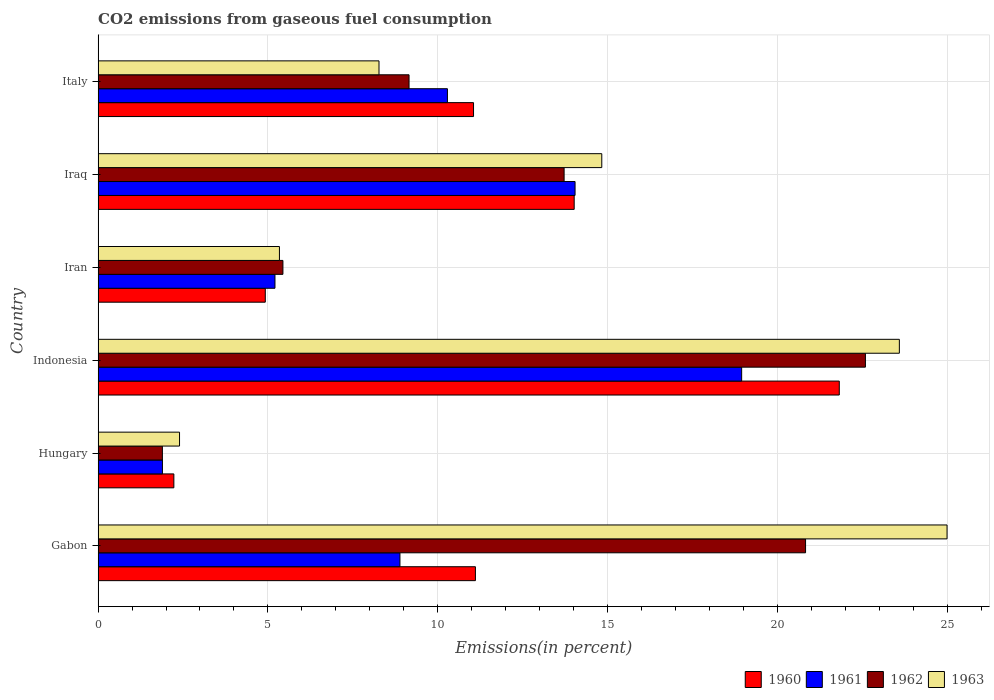How many different coloured bars are there?
Your answer should be very brief. 4. What is the label of the 6th group of bars from the top?
Make the answer very short. Gabon. What is the total CO2 emitted in 1960 in Iran?
Provide a succinct answer. 4.92. Across all countries, what is the maximum total CO2 emitted in 1961?
Ensure brevity in your answer.  18.95. Across all countries, what is the minimum total CO2 emitted in 1962?
Your answer should be compact. 1.89. In which country was the total CO2 emitted in 1963 maximum?
Keep it short and to the point. Gabon. In which country was the total CO2 emitted in 1960 minimum?
Your answer should be very brief. Hungary. What is the total total CO2 emitted in 1962 in the graph?
Offer a very short reply. 73.64. What is the difference between the total CO2 emitted in 1963 in Gabon and that in Italy?
Your answer should be very brief. 16.73. What is the difference between the total CO2 emitted in 1962 in Gabon and the total CO2 emitted in 1960 in Indonesia?
Offer a terse response. -0.99. What is the average total CO2 emitted in 1960 per country?
Offer a terse response. 10.86. What is the difference between the total CO2 emitted in 1961 and total CO2 emitted in 1960 in Indonesia?
Your answer should be compact. -2.87. In how many countries, is the total CO2 emitted in 1962 greater than 14 %?
Provide a short and direct response. 2. What is the ratio of the total CO2 emitted in 1963 in Indonesia to that in Iran?
Your response must be concise. 4.42. What is the difference between the highest and the second highest total CO2 emitted in 1962?
Give a very brief answer. 1.76. What is the difference between the highest and the lowest total CO2 emitted in 1961?
Offer a very short reply. 17.06. In how many countries, is the total CO2 emitted in 1962 greater than the average total CO2 emitted in 1962 taken over all countries?
Offer a terse response. 3. Is the sum of the total CO2 emitted in 1962 in Gabon and Iran greater than the maximum total CO2 emitted in 1960 across all countries?
Provide a short and direct response. Yes. Is it the case that in every country, the sum of the total CO2 emitted in 1963 and total CO2 emitted in 1960 is greater than the sum of total CO2 emitted in 1961 and total CO2 emitted in 1962?
Your response must be concise. No. What does the 4th bar from the top in Iraq represents?
Your answer should be compact. 1960. What does the 4th bar from the bottom in Gabon represents?
Make the answer very short. 1963. Is it the case that in every country, the sum of the total CO2 emitted in 1960 and total CO2 emitted in 1963 is greater than the total CO2 emitted in 1961?
Provide a short and direct response. Yes. How many bars are there?
Make the answer very short. 24. How many countries are there in the graph?
Provide a succinct answer. 6. How are the legend labels stacked?
Your response must be concise. Horizontal. What is the title of the graph?
Your answer should be compact. CO2 emissions from gaseous fuel consumption. What is the label or title of the X-axis?
Offer a very short reply. Emissions(in percent). What is the label or title of the Y-axis?
Your answer should be compact. Country. What is the Emissions(in percent) in 1960 in Gabon?
Your answer should be very brief. 11.11. What is the Emissions(in percent) of 1961 in Gabon?
Ensure brevity in your answer.  8.89. What is the Emissions(in percent) of 1962 in Gabon?
Offer a terse response. 20.83. What is the Emissions(in percent) in 1963 in Gabon?
Provide a short and direct response. 25. What is the Emissions(in percent) of 1960 in Hungary?
Your answer should be very brief. 2.23. What is the Emissions(in percent) in 1961 in Hungary?
Ensure brevity in your answer.  1.89. What is the Emissions(in percent) in 1962 in Hungary?
Provide a short and direct response. 1.89. What is the Emissions(in percent) in 1963 in Hungary?
Your answer should be very brief. 2.4. What is the Emissions(in percent) of 1960 in Indonesia?
Your answer should be compact. 21.83. What is the Emissions(in percent) of 1961 in Indonesia?
Provide a short and direct response. 18.95. What is the Emissions(in percent) in 1962 in Indonesia?
Offer a very short reply. 22.6. What is the Emissions(in percent) of 1963 in Indonesia?
Provide a succinct answer. 23.6. What is the Emissions(in percent) of 1960 in Iran?
Offer a terse response. 4.92. What is the Emissions(in percent) in 1961 in Iran?
Your answer should be compact. 5.21. What is the Emissions(in percent) of 1962 in Iran?
Ensure brevity in your answer.  5.44. What is the Emissions(in percent) in 1963 in Iran?
Keep it short and to the point. 5.34. What is the Emissions(in percent) of 1960 in Iraq?
Your response must be concise. 14.02. What is the Emissions(in percent) of 1961 in Iraq?
Your answer should be very brief. 14.05. What is the Emissions(in percent) in 1962 in Iraq?
Your response must be concise. 13.72. What is the Emissions(in percent) of 1963 in Iraq?
Make the answer very short. 14.83. What is the Emissions(in percent) of 1960 in Italy?
Your response must be concise. 11.06. What is the Emissions(in percent) of 1961 in Italy?
Offer a terse response. 10.29. What is the Emissions(in percent) in 1962 in Italy?
Provide a short and direct response. 9.16. What is the Emissions(in percent) in 1963 in Italy?
Your answer should be very brief. 8.27. Across all countries, what is the maximum Emissions(in percent) of 1960?
Provide a succinct answer. 21.83. Across all countries, what is the maximum Emissions(in percent) of 1961?
Give a very brief answer. 18.95. Across all countries, what is the maximum Emissions(in percent) in 1962?
Your response must be concise. 22.6. Across all countries, what is the maximum Emissions(in percent) of 1963?
Ensure brevity in your answer.  25. Across all countries, what is the minimum Emissions(in percent) of 1960?
Offer a very short reply. 2.23. Across all countries, what is the minimum Emissions(in percent) in 1961?
Offer a terse response. 1.89. Across all countries, what is the minimum Emissions(in percent) in 1962?
Provide a succinct answer. 1.89. Across all countries, what is the minimum Emissions(in percent) of 1963?
Your answer should be very brief. 2.4. What is the total Emissions(in percent) of 1960 in the graph?
Your answer should be very brief. 65.17. What is the total Emissions(in percent) in 1961 in the graph?
Keep it short and to the point. 59.28. What is the total Emissions(in percent) in 1962 in the graph?
Your response must be concise. 73.64. What is the total Emissions(in percent) in 1963 in the graph?
Provide a succinct answer. 79.44. What is the difference between the Emissions(in percent) in 1960 in Gabon and that in Hungary?
Provide a short and direct response. 8.88. What is the difference between the Emissions(in percent) in 1961 in Gabon and that in Hungary?
Ensure brevity in your answer.  6.99. What is the difference between the Emissions(in percent) of 1962 in Gabon and that in Hungary?
Provide a succinct answer. 18.94. What is the difference between the Emissions(in percent) of 1963 in Gabon and that in Hungary?
Your answer should be compact. 22.6. What is the difference between the Emissions(in percent) in 1960 in Gabon and that in Indonesia?
Give a very brief answer. -10.72. What is the difference between the Emissions(in percent) of 1961 in Gabon and that in Indonesia?
Your answer should be compact. -10.06. What is the difference between the Emissions(in percent) in 1962 in Gabon and that in Indonesia?
Keep it short and to the point. -1.76. What is the difference between the Emissions(in percent) of 1963 in Gabon and that in Indonesia?
Make the answer very short. 1.4. What is the difference between the Emissions(in percent) of 1960 in Gabon and that in Iran?
Your answer should be very brief. 6.19. What is the difference between the Emissions(in percent) of 1961 in Gabon and that in Iran?
Your response must be concise. 3.68. What is the difference between the Emissions(in percent) in 1962 in Gabon and that in Iran?
Your response must be concise. 15.39. What is the difference between the Emissions(in percent) of 1963 in Gabon and that in Iran?
Your answer should be very brief. 19.66. What is the difference between the Emissions(in percent) in 1960 in Gabon and that in Iraq?
Give a very brief answer. -2.91. What is the difference between the Emissions(in percent) in 1961 in Gabon and that in Iraq?
Provide a short and direct response. -5.16. What is the difference between the Emissions(in percent) of 1962 in Gabon and that in Iraq?
Give a very brief answer. 7.11. What is the difference between the Emissions(in percent) in 1963 in Gabon and that in Iraq?
Ensure brevity in your answer.  10.17. What is the difference between the Emissions(in percent) of 1960 in Gabon and that in Italy?
Ensure brevity in your answer.  0.06. What is the difference between the Emissions(in percent) in 1961 in Gabon and that in Italy?
Make the answer very short. -1.4. What is the difference between the Emissions(in percent) in 1962 in Gabon and that in Italy?
Your answer should be compact. 11.68. What is the difference between the Emissions(in percent) of 1963 in Gabon and that in Italy?
Your response must be concise. 16.73. What is the difference between the Emissions(in percent) in 1960 in Hungary and that in Indonesia?
Offer a terse response. -19.6. What is the difference between the Emissions(in percent) in 1961 in Hungary and that in Indonesia?
Ensure brevity in your answer.  -17.06. What is the difference between the Emissions(in percent) in 1962 in Hungary and that in Indonesia?
Offer a terse response. -20.7. What is the difference between the Emissions(in percent) in 1963 in Hungary and that in Indonesia?
Provide a short and direct response. -21.2. What is the difference between the Emissions(in percent) in 1960 in Hungary and that in Iran?
Make the answer very short. -2.69. What is the difference between the Emissions(in percent) in 1961 in Hungary and that in Iran?
Keep it short and to the point. -3.31. What is the difference between the Emissions(in percent) in 1962 in Hungary and that in Iran?
Your answer should be very brief. -3.55. What is the difference between the Emissions(in percent) of 1963 in Hungary and that in Iran?
Your answer should be compact. -2.94. What is the difference between the Emissions(in percent) of 1960 in Hungary and that in Iraq?
Your response must be concise. -11.79. What is the difference between the Emissions(in percent) of 1961 in Hungary and that in Iraq?
Make the answer very short. -12.15. What is the difference between the Emissions(in percent) in 1962 in Hungary and that in Iraq?
Make the answer very short. -11.83. What is the difference between the Emissions(in percent) in 1963 in Hungary and that in Iraq?
Your answer should be very brief. -12.43. What is the difference between the Emissions(in percent) of 1960 in Hungary and that in Italy?
Provide a succinct answer. -8.82. What is the difference between the Emissions(in percent) in 1961 in Hungary and that in Italy?
Your answer should be very brief. -8.39. What is the difference between the Emissions(in percent) of 1962 in Hungary and that in Italy?
Make the answer very short. -7.26. What is the difference between the Emissions(in percent) of 1963 in Hungary and that in Italy?
Keep it short and to the point. -5.87. What is the difference between the Emissions(in percent) in 1960 in Indonesia and that in Iran?
Offer a terse response. 16.9. What is the difference between the Emissions(in percent) in 1961 in Indonesia and that in Iran?
Make the answer very short. 13.74. What is the difference between the Emissions(in percent) in 1962 in Indonesia and that in Iran?
Give a very brief answer. 17.15. What is the difference between the Emissions(in percent) of 1963 in Indonesia and that in Iran?
Give a very brief answer. 18.26. What is the difference between the Emissions(in percent) in 1960 in Indonesia and that in Iraq?
Offer a very short reply. 7.81. What is the difference between the Emissions(in percent) of 1961 in Indonesia and that in Iraq?
Your answer should be very brief. 4.91. What is the difference between the Emissions(in percent) of 1962 in Indonesia and that in Iraq?
Ensure brevity in your answer.  8.87. What is the difference between the Emissions(in percent) in 1963 in Indonesia and that in Iraq?
Offer a very short reply. 8.76. What is the difference between the Emissions(in percent) in 1960 in Indonesia and that in Italy?
Your response must be concise. 10.77. What is the difference between the Emissions(in percent) in 1961 in Indonesia and that in Italy?
Keep it short and to the point. 8.66. What is the difference between the Emissions(in percent) of 1962 in Indonesia and that in Italy?
Provide a short and direct response. 13.44. What is the difference between the Emissions(in percent) in 1963 in Indonesia and that in Italy?
Your response must be concise. 15.32. What is the difference between the Emissions(in percent) in 1960 in Iran and that in Iraq?
Make the answer very short. -9.1. What is the difference between the Emissions(in percent) in 1961 in Iran and that in Iraq?
Provide a short and direct response. -8.84. What is the difference between the Emissions(in percent) in 1962 in Iran and that in Iraq?
Provide a short and direct response. -8.28. What is the difference between the Emissions(in percent) of 1963 in Iran and that in Iraq?
Provide a succinct answer. -9.49. What is the difference between the Emissions(in percent) of 1960 in Iran and that in Italy?
Make the answer very short. -6.13. What is the difference between the Emissions(in percent) of 1961 in Iran and that in Italy?
Offer a terse response. -5.08. What is the difference between the Emissions(in percent) of 1962 in Iran and that in Italy?
Offer a very short reply. -3.71. What is the difference between the Emissions(in percent) in 1963 in Iran and that in Italy?
Your answer should be compact. -2.93. What is the difference between the Emissions(in percent) of 1960 in Iraq and that in Italy?
Give a very brief answer. 2.96. What is the difference between the Emissions(in percent) of 1961 in Iraq and that in Italy?
Provide a succinct answer. 3.76. What is the difference between the Emissions(in percent) of 1962 in Iraq and that in Italy?
Make the answer very short. 4.57. What is the difference between the Emissions(in percent) in 1963 in Iraq and that in Italy?
Your response must be concise. 6.56. What is the difference between the Emissions(in percent) in 1960 in Gabon and the Emissions(in percent) in 1961 in Hungary?
Provide a succinct answer. 9.22. What is the difference between the Emissions(in percent) in 1960 in Gabon and the Emissions(in percent) in 1962 in Hungary?
Offer a very short reply. 9.22. What is the difference between the Emissions(in percent) of 1960 in Gabon and the Emissions(in percent) of 1963 in Hungary?
Provide a short and direct response. 8.71. What is the difference between the Emissions(in percent) in 1961 in Gabon and the Emissions(in percent) in 1962 in Hungary?
Your response must be concise. 7. What is the difference between the Emissions(in percent) in 1961 in Gabon and the Emissions(in percent) in 1963 in Hungary?
Offer a very short reply. 6.49. What is the difference between the Emissions(in percent) of 1962 in Gabon and the Emissions(in percent) of 1963 in Hungary?
Offer a very short reply. 18.44. What is the difference between the Emissions(in percent) of 1960 in Gabon and the Emissions(in percent) of 1961 in Indonesia?
Keep it short and to the point. -7.84. What is the difference between the Emissions(in percent) of 1960 in Gabon and the Emissions(in percent) of 1962 in Indonesia?
Offer a very short reply. -11.48. What is the difference between the Emissions(in percent) in 1960 in Gabon and the Emissions(in percent) in 1963 in Indonesia?
Ensure brevity in your answer.  -12.48. What is the difference between the Emissions(in percent) in 1961 in Gabon and the Emissions(in percent) in 1962 in Indonesia?
Offer a very short reply. -13.71. What is the difference between the Emissions(in percent) in 1961 in Gabon and the Emissions(in percent) in 1963 in Indonesia?
Your answer should be very brief. -14.71. What is the difference between the Emissions(in percent) of 1962 in Gabon and the Emissions(in percent) of 1963 in Indonesia?
Your response must be concise. -2.76. What is the difference between the Emissions(in percent) in 1960 in Gabon and the Emissions(in percent) in 1961 in Iran?
Make the answer very short. 5.9. What is the difference between the Emissions(in percent) of 1960 in Gabon and the Emissions(in percent) of 1962 in Iran?
Your answer should be very brief. 5.67. What is the difference between the Emissions(in percent) of 1960 in Gabon and the Emissions(in percent) of 1963 in Iran?
Your response must be concise. 5.77. What is the difference between the Emissions(in percent) in 1961 in Gabon and the Emissions(in percent) in 1962 in Iran?
Your answer should be very brief. 3.45. What is the difference between the Emissions(in percent) of 1961 in Gabon and the Emissions(in percent) of 1963 in Iran?
Your response must be concise. 3.55. What is the difference between the Emissions(in percent) in 1962 in Gabon and the Emissions(in percent) in 1963 in Iran?
Your answer should be compact. 15.49. What is the difference between the Emissions(in percent) of 1960 in Gabon and the Emissions(in percent) of 1961 in Iraq?
Provide a succinct answer. -2.93. What is the difference between the Emissions(in percent) of 1960 in Gabon and the Emissions(in percent) of 1962 in Iraq?
Ensure brevity in your answer.  -2.61. What is the difference between the Emissions(in percent) of 1960 in Gabon and the Emissions(in percent) of 1963 in Iraq?
Provide a short and direct response. -3.72. What is the difference between the Emissions(in percent) in 1961 in Gabon and the Emissions(in percent) in 1962 in Iraq?
Ensure brevity in your answer.  -4.83. What is the difference between the Emissions(in percent) in 1961 in Gabon and the Emissions(in percent) in 1963 in Iraq?
Your answer should be very brief. -5.94. What is the difference between the Emissions(in percent) of 1962 in Gabon and the Emissions(in percent) of 1963 in Iraq?
Keep it short and to the point. 6. What is the difference between the Emissions(in percent) of 1960 in Gabon and the Emissions(in percent) of 1961 in Italy?
Your answer should be compact. 0.82. What is the difference between the Emissions(in percent) in 1960 in Gabon and the Emissions(in percent) in 1962 in Italy?
Give a very brief answer. 1.95. What is the difference between the Emissions(in percent) in 1960 in Gabon and the Emissions(in percent) in 1963 in Italy?
Your answer should be very brief. 2.84. What is the difference between the Emissions(in percent) of 1961 in Gabon and the Emissions(in percent) of 1962 in Italy?
Ensure brevity in your answer.  -0.27. What is the difference between the Emissions(in percent) of 1961 in Gabon and the Emissions(in percent) of 1963 in Italy?
Offer a very short reply. 0.62. What is the difference between the Emissions(in percent) in 1962 in Gabon and the Emissions(in percent) in 1963 in Italy?
Ensure brevity in your answer.  12.56. What is the difference between the Emissions(in percent) of 1960 in Hungary and the Emissions(in percent) of 1961 in Indonesia?
Offer a terse response. -16.72. What is the difference between the Emissions(in percent) in 1960 in Hungary and the Emissions(in percent) in 1962 in Indonesia?
Your answer should be very brief. -20.37. What is the difference between the Emissions(in percent) in 1960 in Hungary and the Emissions(in percent) in 1963 in Indonesia?
Offer a terse response. -21.36. What is the difference between the Emissions(in percent) of 1961 in Hungary and the Emissions(in percent) of 1962 in Indonesia?
Give a very brief answer. -20.7. What is the difference between the Emissions(in percent) of 1961 in Hungary and the Emissions(in percent) of 1963 in Indonesia?
Your response must be concise. -21.7. What is the difference between the Emissions(in percent) of 1962 in Hungary and the Emissions(in percent) of 1963 in Indonesia?
Give a very brief answer. -21.7. What is the difference between the Emissions(in percent) in 1960 in Hungary and the Emissions(in percent) in 1961 in Iran?
Offer a terse response. -2.98. What is the difference between the Emissions(in percent) of 1960 in Hungary and the Emissions(in percent) of 1962 in Iran?
Your response must be concise. -3.21. What is the difference between the Emissions(in percent) of 1960 in Hungary and the Emissions(in percent) of 1963 in Iran?
Make the answer very short. -3.11. What is the difference between the Emissions(in percent) of 1961 in Hungary and the Emissions(in percent) of 1962 in Iran?
Ensure brevity in your answer.  -3.55. What is the difference between the Emissions(in percent) in 1961 in Hungary and the Emissions(in percent) in 1963 in Iran?
Provide a short and direct response. -3.45. What is the difference between the Emissions(in percent) of 1962 in Hungary and the Emissions(in percent) of 1963 in Iran?
Ensure brevity in your answer.  -3.45. What is the difference between the Emissions(in percent) of 1960 in Hungary and the Emissions(in percent) of 1961 in Iraq?
Your answer should be compact. -11.81. What is the difference between the Emissions(in percent) of 1960 in Hungary and the Emissions(in percent) of 1962 in Iraq?
Provide a succinct answer. -11.49. What is the difference between the Emissions(in percent) of 1960 in Hungary and the Emissions(in percent) of 1963 in Iraq?
Provide a succinct answer. -12.6. What is the difference between the Emissions(in percent) in 1961 in Hungary and the Emissions(in percent) in 1962 in Iraq?
Your answer should be compact. -11.83. What is the difference between the Emissions(in percent) in 1961 in Hungary and the Emissions(in percent) in 1963 in Iraq?
Offer a very short reply. -12.94. What is the difference between the Emissions(in percent) in 1962 in Hungary and the Emissions(in percent) in 1963 in Iraq?
Ensure brevity in your answer.  -12.94. What is the difference between the Emissions(in percent) in 1960 in Hungary and the Emissions(in percent) in 1961 in Italy?
Your answer should be very brief. -8.06. What is the difference between the Emissions(in percent) of 1960 in Hungary and the Emissions(in percent) of 1962 in Italy?
Keep it short and to the point. -6.93. What is the difference between the Emissions(in percent) in 1960 in Hungary and the Emissions(in percent) in 1963 in Italy?
Your answer should be compact. -6.04. What is the difference between the Emissions(in percent) of 1961 in Hungary and the Emissions(in percent) of 1962 in Italy?
Ensure brevity in your answer.  -7.26. What is the difference between the Emissions(in percent) in 1961 in Hungary and the Emissions(in percent) in 1963 in Italy?
Make the answer very short. -6.38. What is the difference between the Emissions(in percent) of 1962 in Hungary and the Emissions(in percent) of 1963 in Italy?
Provide a succinct answer. -6.38. What is the difference between the Emissions(in percent) of 1960 in Indonesia and the Emissions(in percent) of 1961 in Iran?
Provide a succinct answer. 16.62. What is the difference between the Emissions(in percent) of 1960 in Indonesia and the Emissions(in percent) of 1962 in Iran?
Provide a short and direct response. 16.38. What is the difference between the Emissions(in percent) in 1960 in Indonesia and the Emissions(in percent) in 1963 in Iran?
Ensure brevity in your answer.  16.49. What is the difference between the Emissions(in percent) of 1961 in Indonesia and the Emissions(in percent) of 1962 in Iran?
Give a very brief answer. 13.51. What is the difference between the Emissions(in percent) of 1961 in Indonesia and the Emissions(in percent) of 1963 in Iran?
Provide a succinct answer. 13.61. What is the difference between the Emissions(in percent) of 1962 in Indonesia and the Emissions(in percent) of 1963 in Iran?
Keep it short and to the point. 17.26. What is the difference between the Emissions(in percent) of 1960 in Indonesia and the Emissions(in percent) of 1961 in Iraq?
Provide a succinct answer. 7.78. What is the difference between the Emissions(in percent) of 1960 in Indonesia and the Emissions(in percent) of 1962 in Iraq?
Ensure brevity in your answer.  8.1. What is the difference between the Emissions(in percent) of 1960 in Indonesia and the Emissions(in percent) of 1963 in Iraq?
Provide a succinct answer. 6.99. What is the difference between the Emissions(in percent) of 1961 in Indonesia and the Emissions(in percent) of 1962 in Iraq?
Provide a short and direct response. 5.23. What is the difference between the Emissions(in percent) in 1961 in Indonesia and the Emissions(in percent) in 1963 in Iraq?
Provide a short and direct response. 4.12. What is the difference between the Emissions(in percent) in 1962 in Indonesia and the Emissions(in percent) in 1963 in Iraq?
Keep it short and to the point. 7.76. What is the difference between the Emissions(in percent) of 1960 in Indonesia and the Emissions(in percent) of 1961 in Italy?
Provide a short and direct response. 11.54. What is the difference between the Emissions(in percent) in 1960 in Indonesia and the Emissions(in percent) in 1962 in Italy?
Ensure brevity in your answer.  12.67. What is the difference between the Emissions(in percent) in 1960 in Indonesia and the Emissions(in percent) in 1963 in Italy?
Your answer should be compact. 13.55. What is the difference between the Emissions(in percent) in 1961 in Indonesia and the Emissions(in percent) in 1962 in Italy?
Your response must be concise. 9.8. What is the difference between the Emissions(in percent) of 1961 in Indonesia and the Emissions(in percent) of 1963 in Italy?
Provide a short and direct response. 10.68. What is the difference between the Emissions(in percent) in 1962 in Indonesia and the Emissions(in percent) in 1963 in Italy?
Your response must be concise. 14.32. What is the difference between the Emissions(in percent) of 1960 in Iran and the Emissions(in percent) of 1961 in Iraq?
Your answer should be very brief. -9.12. What is the difference between the Emissions(in percent) in 1960 in Iran and the Emissions(in percent) in 1962 in Iraq?
Make the answer very short. -8.8. What is the difference between the Emissions(in percent) in 1960 in Iran and the Emissions(in percent) in 1963 in Iraq?
Offer a terse response. -9.91. What is the difference between the Emissions(in percent) in 1961 in Iran and the Emissions(in percent) in 1962 in Iraq?
Your answer should be very brief. -8.51. What is the difference between the Emissions(in percent) in 1961 in Iran and the Emissions(in percent) in 1963 in Iraq?
Provide a short and direct response. -9.62. What is the difference between the Emissions(in percent) of 1962 in Iran and the Emissions(in percent) of 1963 in Iraq?
Make the answer very short. -9.39. What is the difference between the Emissions(in percent) of 1960 in Iran and the Emissions(in percent) of 1961 in Italy?
Offer a terse response. -5.36. What is the difference between the Emissions(in percent) in 1960 in Iran and the Emissions(in percent) in 1962 in Italy?
Provide a succinct answer. -4.23. What is the difference between the Emissions(in percent) in 1960 in Iran and the Emissions(in percent) in 1963 in Italy?
Make the answer very short. -3.35. What is the difference between the Emissions(in percent) of 1961 in Iran and the Emissions(in percent) of 1962 in Italy?
Ensure brevity in your answer.  -3.95. What is the difference between the Emissions(in percent) of 1961 in Iran and the Emissions(in percent) of 1963 in Italy?
Your answer should be very brief. -3.06. What is the difference between the Emissions(in percent) of 1962 in Iran and the Emissions(in percent) of 1963 in Italy?
Offer a terse response. -2.83. What is the difference between the Emissions(in percent) of 1960 in Iraq and the Emissions(in percent) of 1961 in Italy?
Offer a very short reply. 3.73. What is the difference between the Emissions(in percent) of 1960 in Iraq and the Emissions(in percent) of 1962 in Italy?
Provide a succinct answer. 4.86. What is the difference between the Emissions(in percent) of 1960 in Iraq and the Emissions(in percent) of 1963 in Italy?
Your answer should be compact. 5.75. What is the difference between the Emissions(in percent) of 1961 in Iraq and the Emissions(in percent) of 1962 in Italy?
Your answer should be very brief. 4.89. What is the difference between the Emissions(in percent) of 1961 in Iraq and the Emissions(in percent) of 1963 in Italy?
Your answer should be compact. 5.77. What is the difference between the Emissions(in percent) of 1962 in Iraq and the Emissions(in percent) of 1963 in Italy?
Ensure brevity in your answer.  5.45. What is the average Emissions(in percent) of 1960 per country?
Provide a succinct answer. 10.86. What is the average Emissions(in percent) in 1961 per country?
Offer a terse response. 9.88. What is the average Emissions(in percent) of 1962 per country?
Provide a succinct answer. 12.27. What is the average Emissions(in percent) of 1963 per country?
Offer a very short reply. 13.24. What is the difference between the Emissions(in percent) in 1960 and Emissions(in percent) in 1961 in Gabon?
Your answer should be compact. 2.22. What is the difference between the Emissions(in percent) in 1960 and Emissions(in percent) in 1962 in Gabon?
Offer a very short reply. -9.72. What is the difference between the Emissions(in percent) of 1960 and Emissions(in percent) of 1963 in Gabon?
Provide a succinct answer. -13.89. What is the difference between the Emissions(in percent) in 1961 and Emissions(in percent) in 1962 in Gabon?
Provide a short and direct response. -11.94. What is the difference between the Emissions(in percent) of 1961 and Emissions(in percent) of 1963 in Gabon?
Your response must be concise. -16.11. What is the difference between the Emissions(in percent) of 1962 and Emissions(in percent) of 1963 in Gabon?
Offer a terse response. -4.17. What is the difference between the Emissions(in percent) of 1960 and Emissions(in percent) of 1961 in Hungary?
Your answer should be very brief. 0.34. What is the difference between the Emissions(in percent) of 1960 and Emissions(in percent) of 1962 in Hungary?
Your answer should be compact. 0.34. What is the difference between the Emissions(in percent) of 1960 and Emissions(in percent) of 1963 in Hungary?
Your response must be concise. -0.17. What is the difference between the Emissions(in percent) in 1961 and Emissions(in percent) in 1962 in Hungary?
Offer a very short reply. 0. What is the difference between the Emissions(in percent) in 1961 and Emissions(in percent) in 1963 in Hungary?
Offer a very short reply. -0.5. What is the difference between the Emissions(in percent) in 1962 and Emissions(in percent) in 1963 in Hungary?
Make the answer very short. -0.5. What is the difference between the Emissions(in percent) of 1960 and Emissions(in percent) of 1961 in Indonesia?
Offer a terse response. 2.87. What is the difference between the Emissions(in percent) in 1960 and Emissions(in percent) in 1962 in Indonesia?
Your answer should be compact. -0.77. What is the difference between the Emissions(in percent) of 1960 and Emissions(in percent) of 1963 in Indonesia?
Keep it short and to the point. -1.77. What is the difference between the Emissions(in percent) of 1961 and Emissions(in percent) of 1962 in Indonesia?
Keep it short and to the point. -3.64. What is the difference between the Emissions(in percent) of 1961 and Emissions(in percent) of 1963 in Indonesia?
Give a very brief answer. -4.64. What is the difference between the Emissions(in percent) of 1962 and Emissions(in percent) of 1963 in Indonesia?
Offer a terse response. -1. What is the difference between the Emissions(in percent) in 1960 and Emissions(in percent) in 1961 in Iran?
Your response must be concise. -0.29. What is the difference between the Emissions(in percent) of 1960 and Emissions(in percent) of 1962 in Iran?
Offer a very short reply. -0.52. What is the difference between the Emissions(in percent) in 1960 and Emissions(in percent) in 1963 in Iran?
Make the answer very short. -0.42. What is the difference between the Emissions(in percent) in 1961 and Emissions(in percent) in 1962 in Iran?
Offer a very short reply. -0.23. What is the difference between the Emissions(in percent) in 1961 and Emissions(in percent) in 1963 in Iran?
Ensure brevity in your answer.  -0.13. What is the difference between the Emissions(in percent) in 1962 and Emissions(in percent) in 1963 in Iran?
Your answer should be very brief. 0.1. What is the difference between the Emissions(in percent) in 1960 and Emissions(in percent) in 1961 in Iraq?
Offer a terse response. -0.03. What is the difference between the Emissions(in percent) of 1960 and Emissions(in percent) of 1962 in Iraq?
Offer a very short reply. 0.3. What is the difference between the Emissions(in percent) in 1960 and Emissions(in percent) in 1963 in Iraq?
Your answer should be compact. -0.81. What is the difference between the Emissions(in percent) in 1961 and Emissions(in percent) in 1962 in Iraq?
Keep it short and to the point. 0.32. What is the difference between the Emissions(in percent) of 1961 and Emissions(in percent) of 1963 in Iraq?
Offer a very short reply. -0.79. What is the difference between the Emissions(in percent) in 1962 and Emissions(in percent) in 1963 in Iraq?
Provide a short and direct response. -1.11. What is the difference between the Emissions(in percent) of 1960 and Emissions(in percent) of 1961 in Italy?
Your answer should be very brief. 0.77. What is the difference between the Emissions(in percent) in 1960 and Emissions(in percent) in 1962 in Italy?
Ensure brevity in your answer.  1.9. What is the difference between the Emissions(in percent) of 1960 and Emissions(in percent) of 1963 in Italy?
Ensure brevity in your answer.  2.78. What is the difference between the Emissions(in percent) in 1961 and Emissions(in percent) in 1962 in Italy?
Offer a very short reply. 1.13. What is the difference between the Emissions(in percent) of 1961 and Emissions(in percent) of 1963 in Italy?
Offer a terse response. 2.02. What is the difference between the Emissions(in percent) in 1962 and Emissions(in percent) in 1963 in Italy?
Your answer should be compact. 0.88. What is the ratio of the Emissions(in percent) of 1960 in Gabon to that in Hungary?
Provide a succinct answer. 4.98. What is the ratio of the Emissions(in percent) of 1961 in Gabon to that in Hungary?
Provide a succinct answer. 4.69. What is the ratio of the Emissions(in percent) of 1962 in Gabon to that in Hungary?
Offer a very short reply. 11.01. What is the ratio of the Emissions(in percent) of 1963 in Gabon to that in Hungary?
Keep it short and to the point. 10.43. What is the ratio of the Emissions(in percent) of 1960 in Gabon to that in Indonesia?
Offer a very short reply. 0.51. What is the ratio of the Emissions(in percent) in 1961 in Gabon to that in Indonesia?
Provide a succinct answer. 0.47. What is the ratio of the Emissions(in percent) of 1962 in Gabon to that in Indonesia?
Ensure brevity in your answer.  0.92. What is the ratio of the Emissions(in percent) of 1963 in Gabon to that in Indonesia?
Ensure brevity in your answer.  1.06. What is the ratio of the Emissions(in percent) in 1960 in Gabon to that in Iran?
Your answer should be very brief. 2.26. What is the ratio of the Emissions(in percent) of 1961 in Gabon to that in Iran?
Offer a terse response. 1.71. What is the ratio of the Emissions(in percent) of 1962 in Gabon to that in Iran?
Provide a short and direct response. 3.83. What is the ratio of the Emissions(in percent) in 1963 in Gabon to that in Iran?
Provide a succinct answer. 4.68. What is the ratio of the Emissions(in percent) of 1960 in Gabon to that in Iraq?
Provide a succinct answer. 0.79. What is the ratio of the Emissions(in percent) in 1961 in Gabon to that in Iraq?
Your response must be concise. 0.63. What is the ratio of the Emissions(in percent) in 1962 in Gabon to that in Iraq?
Provide a short and direct response. 1.52. What is the ratio of the Emissions(in percent) in 1963 in Gabon to that in Iraq?
Ensure brevity in your answer.  1.69. What is the ratio of the Emissions(in percent) in 1961 in Gabon to that in Italy?
Make the answer very short. 0.86. What is the ratio of the Emissions(in percent) in 1962 in Gabon to that in Italy?
Your answer should be compact. 2.28. What is the ratio of the Emissions(in percent) in 1963 in Gabon to that in Italy?
Your answer should be very brief. 3.02. What is the ratio of the Emissions(in percent) in 1960 in Hungary to that in Indonesia?
Ensure brevity in your answer.  0.1. What is the ratio of the Emissions(in percent) in 1962 in Hungary to that in Indonesia?
Ensure brevity in your answer.  0.08. What is the ratio of the Emissions(in percent) of 1963 in Hungary to that in Indonesia?
Give a very brief answer. 0.1. What is the ratio of the Emissions(in percent) of 1960 in Hungary to that in Iran?
Make the answer very short. 0.45. What is the ratio of the Emissions(in percent) in 1961 in Hungary to that in Iran?
Offer a very short reply. 0.36. What is the ratio of the Emissions(in percent) in 1962 in Hungary to that in Iran?
Your answer should be compact. 0.35. What is the ratio of the Emissions(in percent) in 1963 in Hungary to that in Iran?
Ensure brevity in your answer.  0.45. What is the ratio of the Emissions(in percent) in 1960 in Hungary to that in Iraq?
Your response must be concise. 0.16. What is the ratio of the Emissions(in percent) of 1961 in Hungary to that in Iraq?
Keep it short and to the point. 0.13. What is the ratio of the Emissions(in percent) of 1962 in Hungary to that in Iraq?
Make the answer very short. 0.14. What is the ratio of the Emissions(in percent) of 1963 in Hungary to that in Iraq?
Provide a succinct answer. 0.16. What is the ratio of the Emissions(in percent) in 1960 in Hungary to that in Italy?
Your answer should be compact. 0.2. What is the ratio of the Emissions(in percent) in 1961 in Hungary to that in Italy?
Provide a succinct answer. 0.18. What is the ratio of the Emissions(in percent) in 1962 in Hungary to that in Italy?
Give a very brief answer. 0.21. What is the ratio of the Emissions(in percent) in 1963 in Hungary to that in Italy?
Your answer should be compact. 0.29. What is the ratio of the Emissions(in percent) in 1960 in Indonesia to that in Iran?
Provide a succinct answer. 4.43. What is the ratio of the Emissions(in percent) in 1961 in Indonesia to that in Iran?
Offer a terse response. 3.64. What is the ratio of the Emissions(in percent) in 1962 in Indonesia to that in Iran?
Provide a succinct answer. 4.15. What is the ratio of the Emissions(in percent) of 1963 in Indonesia to that in Iran?
Ensure brevity in your answer.  4.42. What is the ratio of the Emissions(in percent) of 1960 in Indonesia to that in Iraq?
Your answer should be very brief. 1.56. What is the ratio of the Emissions(in percent) in 1961 in Indonesia to that in Iraq?
Keep it short and to the point. 1.35. What is the ratio of the Emissions(in percent) of 1962 in Indonesia to that in Iraq?
Offer a very short reply. 1.65. What is the ratio of the Emissions(in percent) of 1963 in Indonesia to that in Iraq?
Your response must be concise. 1.59. What is the ratio of the Emissions(in percent) in 1960 in Indonesia to that in Italy?
Give a very brief answer. 1.97. What is the ratio of the Emissions(in percent) of 1961 in Indonesia to that in Italy?
Give a very brief answer. 1.84. What is the ratio of the Emissions(in percent) of 1962 in Indonesia to that in Italy?
Give a very brief answer. 2.47. What is the ratio of the Emissions(in percent) of 1963 in Indonesia to that in Italy?
Provide a short and direct response. 2.85. What is the ratio of the Emissions(in percent) of 1960 in Iran to that in Iraq?
Offer a terse response. 0.35. What is the ratio of the Emissions(in percent) in 1961 in Iran to that in Iraq?
Your answer should be compact. 0.37. What is the ratio of the Emissions(in percent) in 1962 in Iran to that in Iraq?
Keep it short and to the point. 0.4. What is the ratio of the Emissions(in percent) in 1963 in Iran to that in Iraq?
Provide a succinct answer. 0.36. What is the ratio of the Emissions(in percent) in 1960 in Iran to that in Italy?
Offer a very short reply. 0.45. What is the ratio of the Emissions(in percent) in 1961 in Iran to that in Italy?
Offer a very short reply. 0.51. What is the ratio of the Emissions(in percent) of 1962 in Iran to that in Italy?
Provide a succinct answer. 0.59. What is the ratio of the Emissions(in percent) in 1963 in Iran to that in Italy?
Your response must be concise. 0.65. What is the ratio of the Emissions(in percent) of 1960 in Iraq to that in Italy?
Provide a succinct answer. 1.27. What is the ratio of the Emissions(in percent) in 1961 in Iraq to that in Italy?
Ensure brevity in your answer.  1.37. What is the ratio of the Emissions(in percent) of 1962 in Iraq to that in Italy?
Ensure brevity in your answer.  1.5. What is the ratio of the Emissions(in percent) of 1963 in Iraq to that in Italy?
Give a very brief answer. 1.79. What is the difference between the highest and the second highest Emissions(in percent) of 1960?
Ensure brevity in your answer.  7.81. What is the difference between the highest and the second highest Emissions(in percent) in 1961?
Keep it short and to the point. 4.91. What is the difference between the highest and the second highest Emissions(in percent) of 1962?
Your answer should be compact. 1.76. What is the difference between the highest and the second highest Emissions(in percent) of 1963?
Your answer should be compact. 1.4. What is the difference between the highest and the lowest Emissions(in percent) in 1960?
Your answer should be very brief. 19.6. What is the difference between the highest and the lowest Emissions(in percent) in 1961?
Provide a succinct answer. 17.06. What is the difference between the highest and the lowest Emissions(in percent) in 1962?
Your response must be concise. 20.7. What is the difference between the highest and the lowest Emissions(in percent) in 1963?
Offer a terse response. 22.6. 